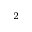Convert formula to latex. <formula><loc_0><loc_0><loc_500><loc_500>_ { 2 }</formula> 